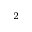Convert formula to latex. <formula><loc_0><loc_0><loc_500><loc_500>_ { 2 }</formula> 